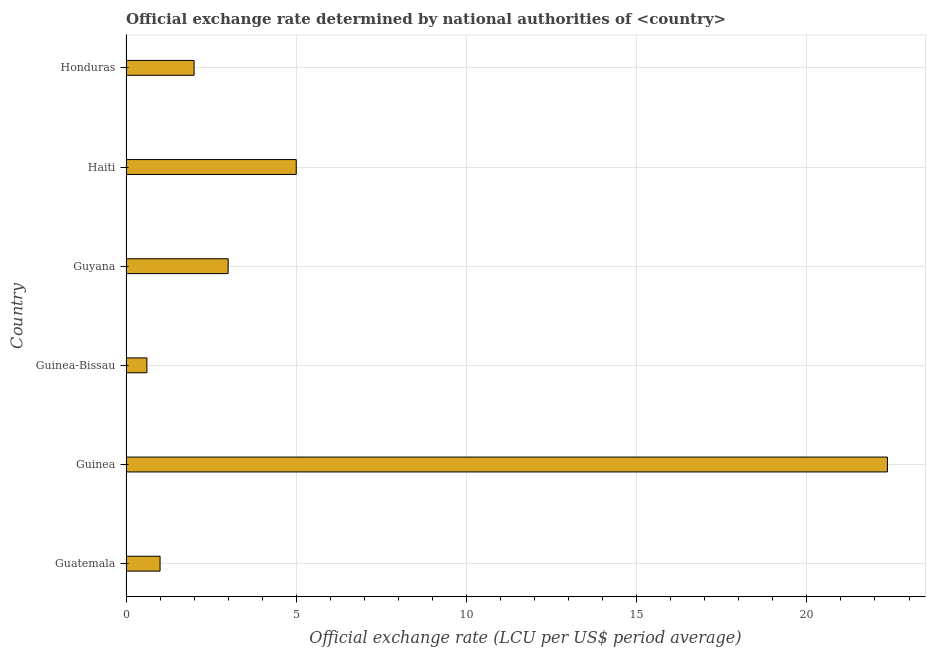Does the graph contain any zero values?
Keep it short and to the point. No. What is the title of the graph?
Give a very brief answer. Official exchange rate determined by national authorities of <country>. What is the label or title of the X-axis?
Provide a short and direct response. Official exchange rate (LCU per US$ period average). What is the label or title of the Y-axis?
Your answer should be compact. Country. What is the official exchange rate in Haiti?
Keep it short and to the point. 5. Across all countries, what is the maximum official exchange rate?
Your answer should be very brief. 22.37. Across all countries, what is the minimum official exchange rate?
Give a very brief answer. 0.61. In which country was the official exchange rate maximum?
Give a very brief answer. Guinea. In which country was the official exchange rate minimum?
Your answer should be compact. Guinea-Bissau. What is the sum of the official exchange rate?
Ensure brevity in your answer.  33.98. What is the difference between the official exchange rate in Guinea-Bissau and Haiti?
Offer a terse response. -4.39. What is the average official exchange rate per country?
Ensure brevity in your answer.  5.66. What is the median official exchange rate?
Provide a succinct answer. 2.5. In how many countries, is the official exchange rate greater than 16 ?
Provide a short and direct response. 1. What is the difference between the highest and the second highest official exchange rate?
Ensure brevity in your answer.  17.37. What is the difference between the highest and the lowest official exchange rate?
Provide a succinct answer. 21.75. Are all the bars in the graph horizontal?
Keep it short and to the point. Yes. How many countries are there in the graph?
Ensure brevity in your answer.  6. What is the Official exchange rate (LCU per US$ period average) in Guatemala?
Your response must be concise. 1. What is the Official exchange rate (LCU per US$ period average) in Guinea?
Give a very brief answer. 22.37. What is the Official exchange rate (LCU per US$ period average) of Guinea-Bissau?
Ensure brevity in your answer.  0.61. What is the Official exchange rate (LCU per US$ period average) of Guyana?
Provide a short and direct response. 3. What is the Official exchange rate (LCU per US$ period average) in Haiti?
Your answer should be compact. 5. What is the Official exchange rate (LCU per US$ period average) in Honduras?
Offer a very short reply. 2. What is the difference between the Official exchange rate (LCU per US$ period average) in Guatemala and Guinea?
Make the answer very short. -21.37. What is the difference between the Official exchange rate (LCU per US$ period average) in Guatemala and Guinea-Bissau?
Provide a succinct answer. 0.39. What is the difference between the Official exchange rate (LCU per US$ period average) in Guatemala and Haiti?
Offer a very short reply. -4. What is the difference between the Official exchange rate (LCU per US$ period average) in Guatemala and Honduras?
Provide a short and direct response. -1. What is the difference between the Official exchange rate (LCU per US$ period average) in Guinea and Guinea-Bissau?
Ensure brevity in your answer.  21.75. What is the difference between the Official exchange rate (LCU per US$ period average) in Guinea and Guyana?
Your answer should be very brief. 19.37. What is the difference between the Official exchange rate (LCU per US$ period average) in Guinea and Haiti?
Keep it short and to the point. 17.37. What is the difference between the Official exchange rate (LCU per US$ period average) in Guinea and Honduras?
Provide a succinct answer. 20.37. What is the difference between the Official exchange rate (LCU per US$ period average) in Guinea-Bissau and Guyana?
Keep it short and to the point. -2.39. What is the difference between the Official exchange rate (LCU per US$ period average) in Guinea-Bissau and Haiti?
Keep it short and to the point. -4.39. What is the difference between the Official exchange rate (LCU per US$ period average) in Guinea-Bissau and Honduras?
Your answer should be very brief. -1.39. What is the difference between the Official exchange rate (LCU per US$ period average) in Guyana and Honduras?
Your answer should be compact. 1. What is the ratio of the Official exchange rate (LCU per US$ period average) in Guatemala to that in Guinea?
Make the answer very short. 0.04. What is the ratio of the Official exchange rate (LCU per US$ period average) in Guatemala to that in Guinea-Bissau?
Give a very brief answer. 1.63. What is the ratio of the Official exchange rate (LCU per US$ period average) in Guatemala to that in Guyana?
Your answer should be compact. 0.33. What is the ratio of the Official exchange rate (LCU per US$ period average) in Guatemala to that in Haiti?
Your answer should be compact. 0.2. What is the ratio of the Official exchange rate (LCU per US$ period average) in Guinea to that in Guinea-Bissau?
Your answer should be compact. 36.47. What is the ratio of the Official exchange rate (LCU per US$ period average) in Guinea to that in Guyana?
Your response must be concise. 7.46. What is the ratio of the Official exchange rate (LCU per US$ period average) in Guinea to that in Haiti?
Your answer should be very brief. 4.47. What is the ratio of the Official exchange rate (LCU per US$ period average) in Guinea to that in Honduras?
Give a very brief answer. 11.18. What is the ratio of the Official exchange rate (LCU per US$ period average) in Guinea-Bissau to that in Guyana?
Offer a terse response. 0.2. What is the ratio of the Official exchange rate (LCU per US$ period average) in Guinea-Bissau to that in Haiti?
Your response must be concise. 0.12. What is the ratio of the Official exchange rate (LCU per US$ period average) in Guinea-Bissau to that in Honduras?
Your answer should be compact. 0.31. What is the ratio of the Official exchange rate (LCU per US$ period average) in Guyana to that in Haiti?
Keep it short and to the point. 0.6. What is the ratio of the Official exchange rate (LCU per US$ period average) in Guyana to that in Honduras?
Your response must be concise. 1.5. 